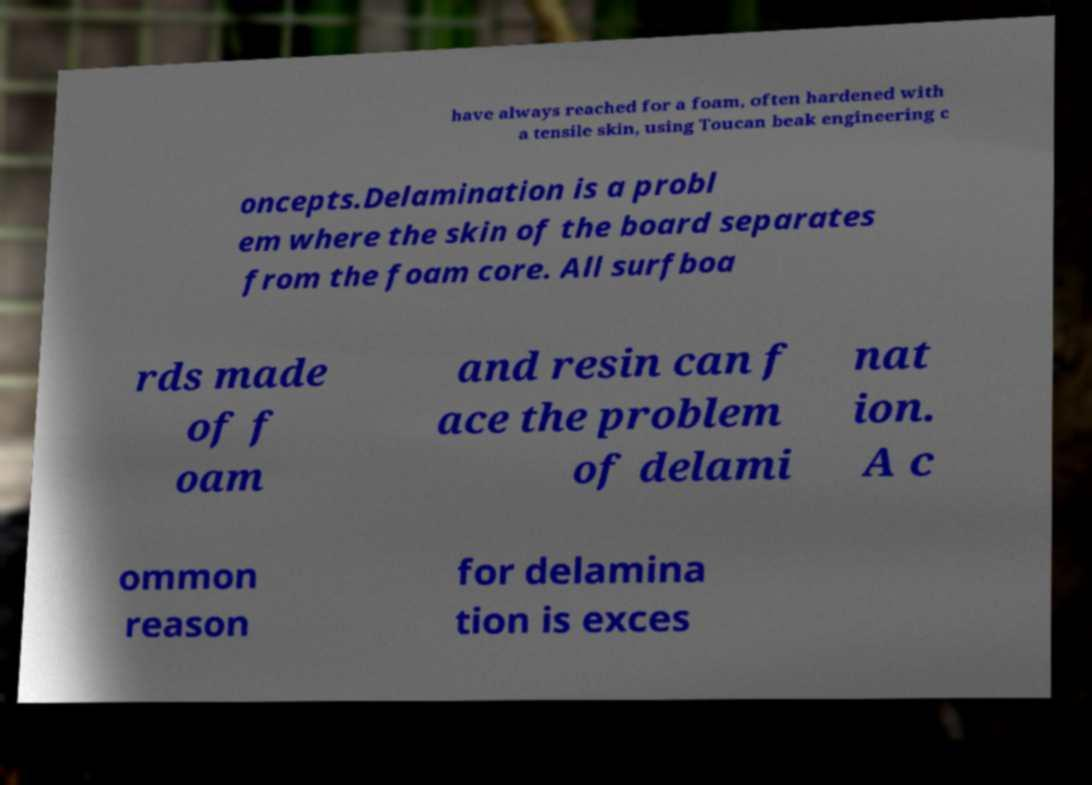Can you read and provide the text displayed in the image?This photo seems to have some interesting text. Can you extract and type it out for me? have always reached for a foam, often hardened with a tensile skin, using Toucan beak engineering c oncepts.Delamination is a probl em where the skin of the board separates from the foam core. All surfboa rds made of f oam and resin can f ace the problem of delami nat ion. A c ommon reason for delamina tion is exces 